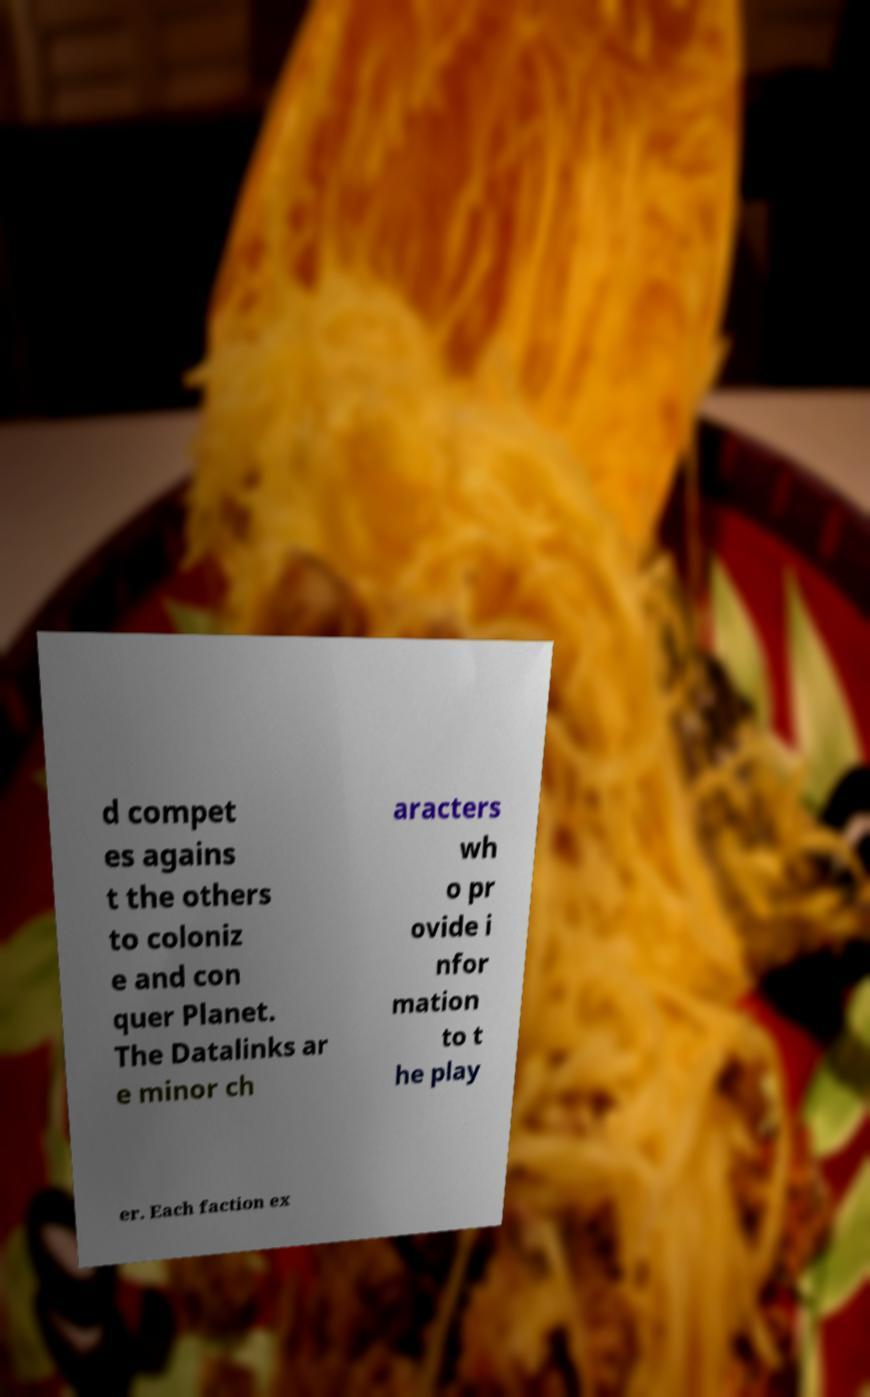Please read and relay the text visible in this image. What does it say? d compet es agains t the others to coloniz e and con quer Planet. The Datalinks ar e minor ch aracters wh o pr ovide i nfor mation to t he play er. Each faction ex 